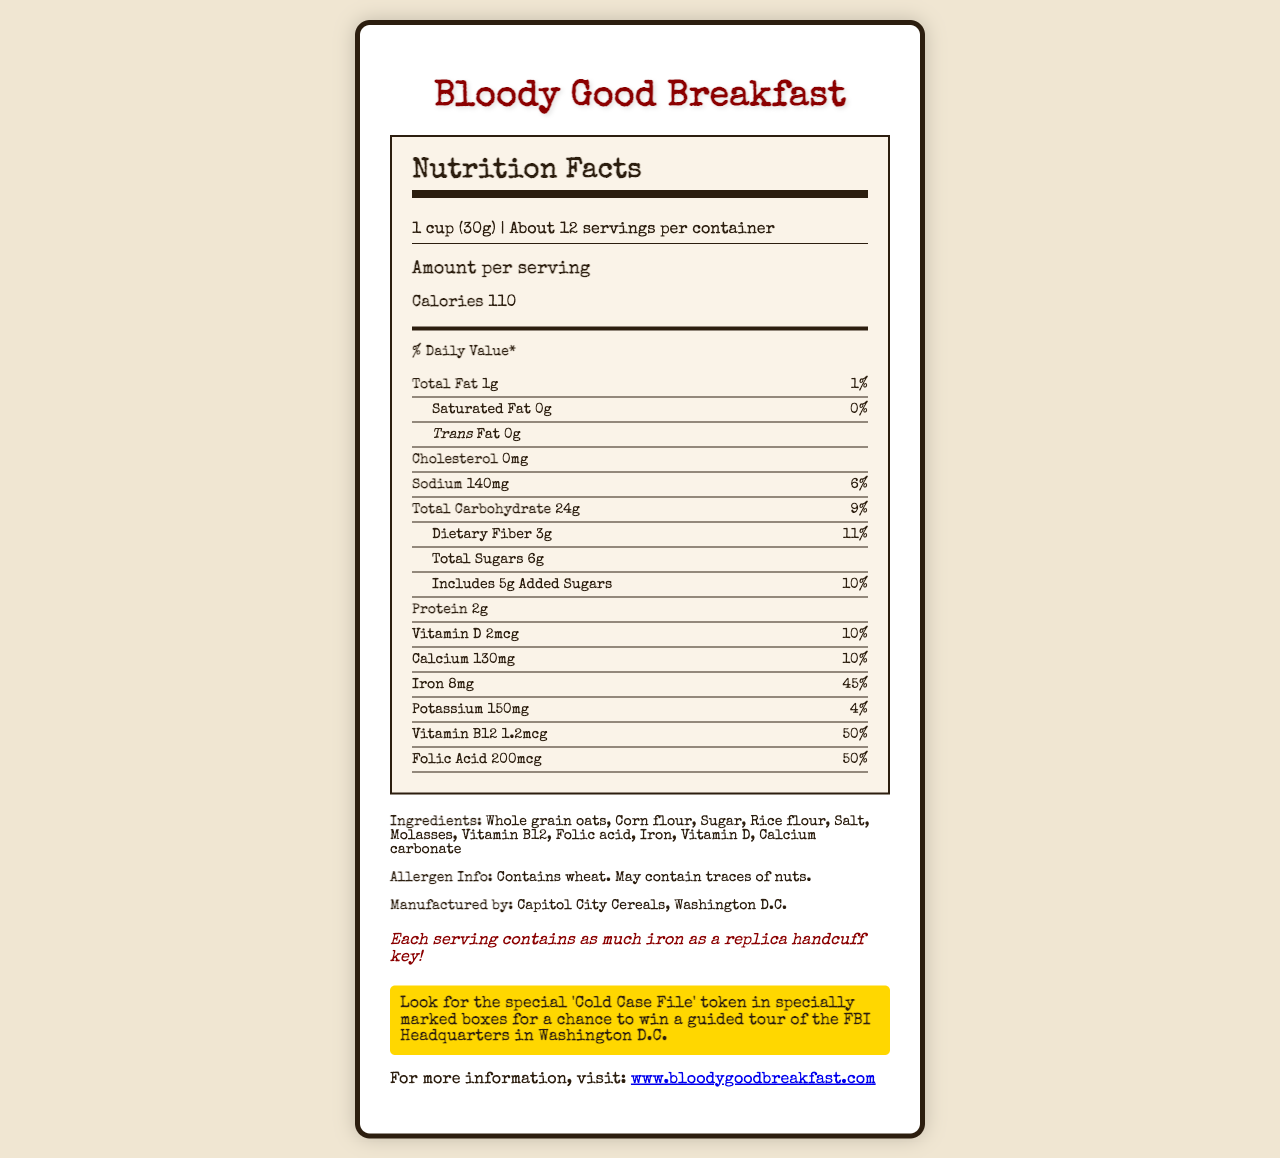what is the serving size? The serving size is mentioned at the top of the Nutrition Facts label as "1 cup (30g)".
Answer: 1 cup (30g) how many servings are there per container? The document states "Servings per container: About 12" at the top.
Answer: About 12 how many calories are in one serving? The document explains that each serving contains "Calories 110".
Answer: 110 what is the amount of total fat in one serving? Under the "Total Fat" section, it states "Amount per serving: Total Fat 1g".
Answer: 1g what percentage of the daily value for iron does one serving have? The percentage daily value for iron is listed as "Iron 45%" on the Nutrition Facts label.
Answer: 45% which vitamin has the highest daily value percentage in this cereal? A. Vitamin D B. Calcium C. Vitamin B12 D. Folic Acid Vitamin B12 has the highest daily value percentage at 50%, as stated in the Vitamin B12 section.
Answer: C. Vitamin B12 how many grams of added sugars are there per serving? A. 0g B. 3g C. 5g D. 6g The document shows "Includes 5g Added Sugars" under the total carbohydrates section.
Answer: C. 5g does the cereal contain any cholesterol? The document explicitly states "Cholesterol 0mg", indicating that there is no cholesterol in the cereal.
Answer: No what is the main idea of this document? The document focuses on presenting comprehensive nutritional information and additional facts and promotions related to the "Bloody Good Breakfast" cereal product.
Answer: The document provides detailed nutritional information about the "Bloody Good Breakfast" cereal, including serving size, calorie content, nutrient amounts, ingredients, allergen information, and additional fun facts and promotional details. who is the manufacturer of the cereal? The document specifies the manufacturer under the ingredients section as "Manufactured by: Capitol City Cereals, Washington D.C."
Answer: Capitol City Cereals, Washington D.C. what is the fun fact mentioned in the document? The document includes a fun fact near the end, stating "Each serving contains as much iron as a replica handcuff key!"
Answer: Each serving contains as much iron as a replica handcuff key! where can you find more information about the cereal? The document provides a website link for more information as "For more information, visit: www.bloodygoodbreakfast.com."
Answer: www.bloodygoodbreakfast.com what is the sodium content per serving in milligrams? The sodium content per serving is indicated as "Sodium 140mg" on the Nutrition Facts label.
Answer: 140mg does the cereal contain any vitamin A? The document does not provide any information regarding the presence of Vitamin A. There is no mention of Vitamin A in the Nutrition Facts or the ingredients list.
Answer: Cannot be determined what is the mystery prize mentioned in the document? The mystery prize is detailed in the promotional section, mentioning, "Look for the special 'Cold Case File' token in specially marked boxes for a chance to win a guided tour of the FBI Headquarters in Washington D.C."
Answer: A chance to win a guided tour of the FBI Headquarters in Washington D.C. which of these is not an ingredient in the cereal? A. Whole grain oats B. Vitamin C C. Molasses D. Rice flour The ingredients list includes Whole grain oats, Molasses, and Rice flour, but does not mention Vitamin C.
Answer: B. Vitamin C 